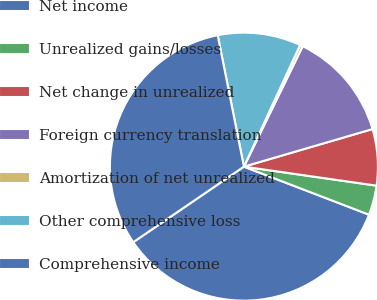<chart> <loc_0><loc_0><loc_500><loc_500><pie_chart><fcel>Net income<fcel>Unrealized gains/losses<fcel>Net change in unrealized<fcel>Foreign currency translation<fcel>Amortization of net unrealized<fcel>Other comprehensive loss<fcel>Comprehensive income<nl><fcel>34.63%<fcel>3.57%<fcel>6.79%<fcel>13.25%<fcel>0.34%<fcel>10.02%<fcel>31.4%<nl></chart> 